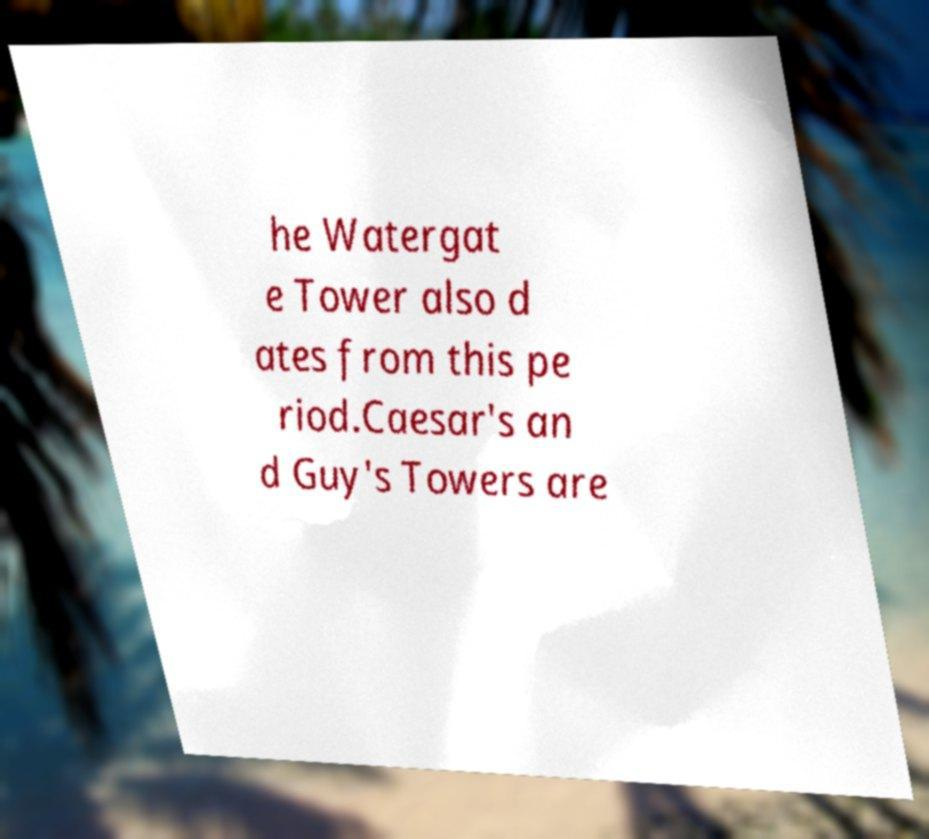Could you assist in decoding the text presented in this image and type it out clearly? he Watergat e Tower also d ates from this pe riod.Caesar's an d Guy's Towers are 